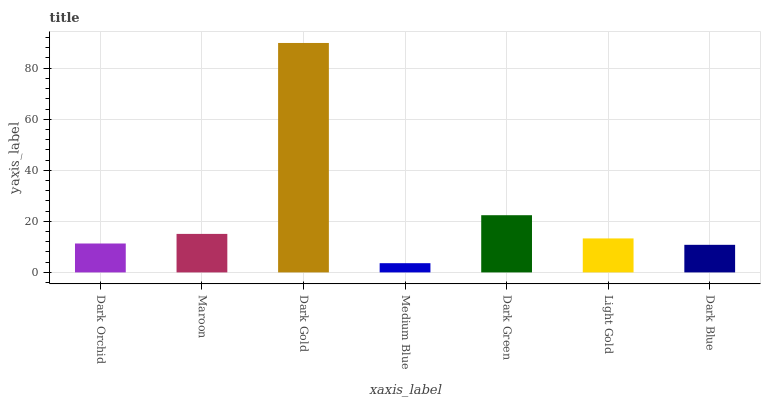Is Medium Blue the minimum?
Answer yes or no. Yes. Is Dark Gold the maximum?
Answer yes or no. Yes. Is Maroon the minimum?
Answer yes or no. No. Is Maroon the maximum?
Answer yes or no. No. Is Maroon greater than Dark Orchid?
Answer yes or no. Yes. Is Dark Orchid less than Maroon?
Answer yes or no. Yes. Is Dark Orchid greater than Maroon?
Answer yes or no. No. Is Maroon less than Dark Orchid?
Answer yes or no. No. Is Light Gold the high median?
Answer yes or no. Yes. Is Light Gold the low median?
Answer yes or no. Yes. Is Dark Green the high median?
Answer yes or no. No. Is Dark Gold the low median?
Answer yes or no. No. 